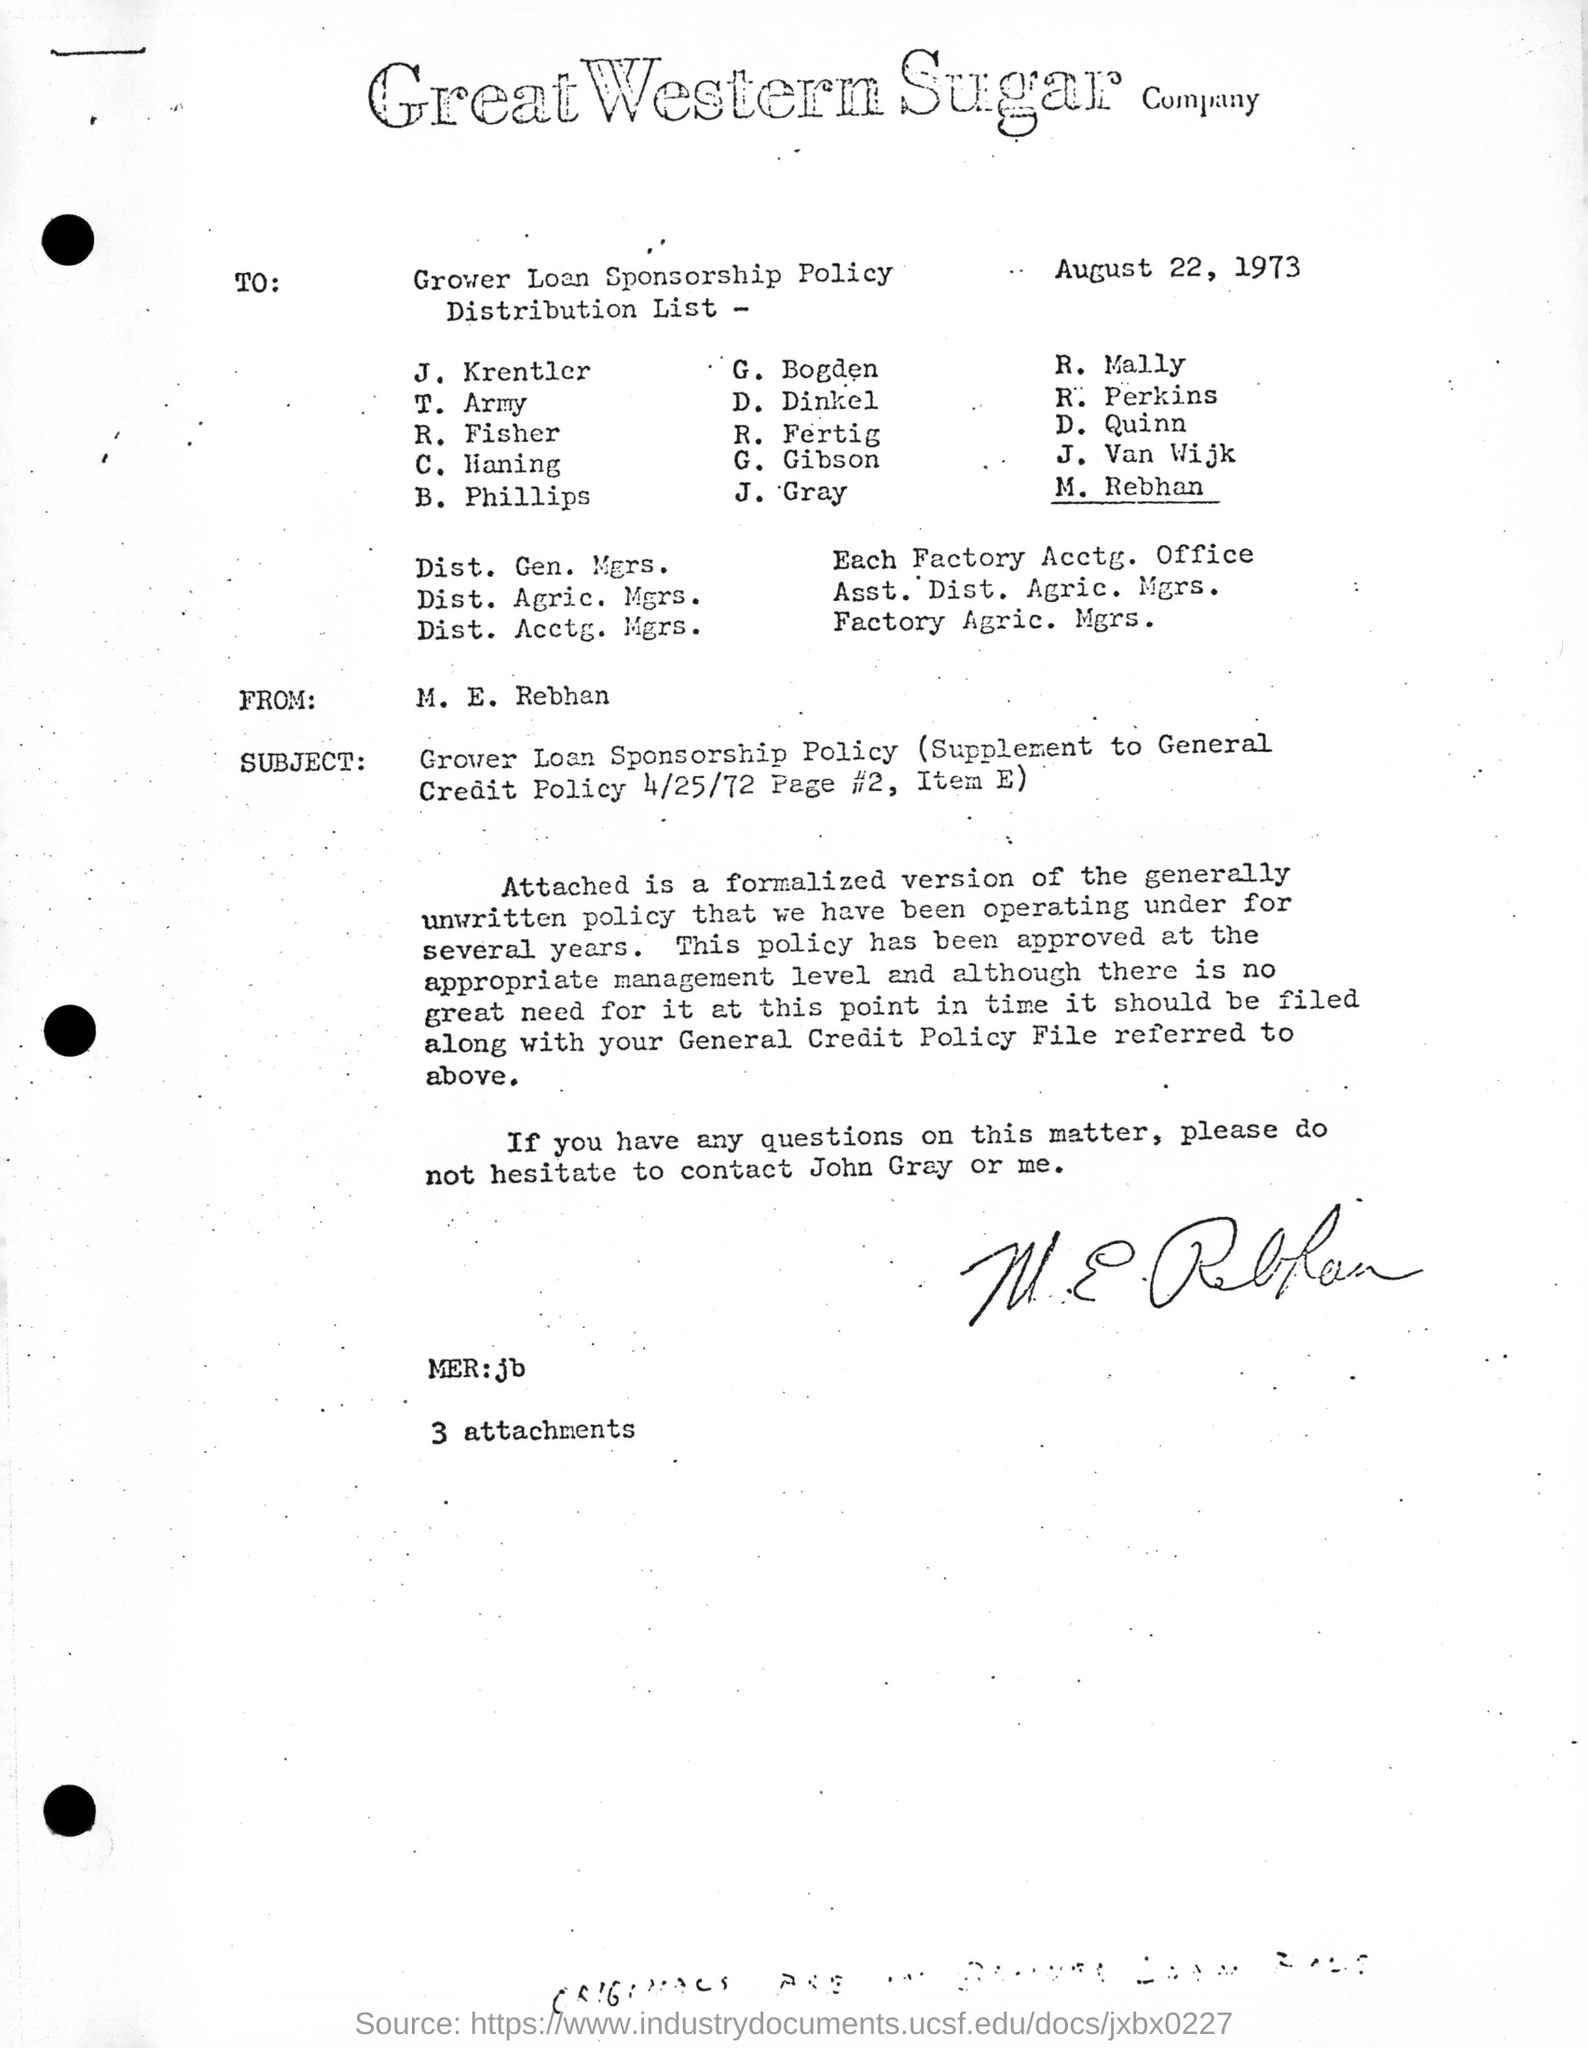List a handful of essential elements in this visual. The date on the letter is August 22, 1973. The author of this letter is M. E. Rebhan... The letter is addressed to the Grower Loan Sponsorship Policy. The letterhead bears the name of the Great Western Sugar company. 